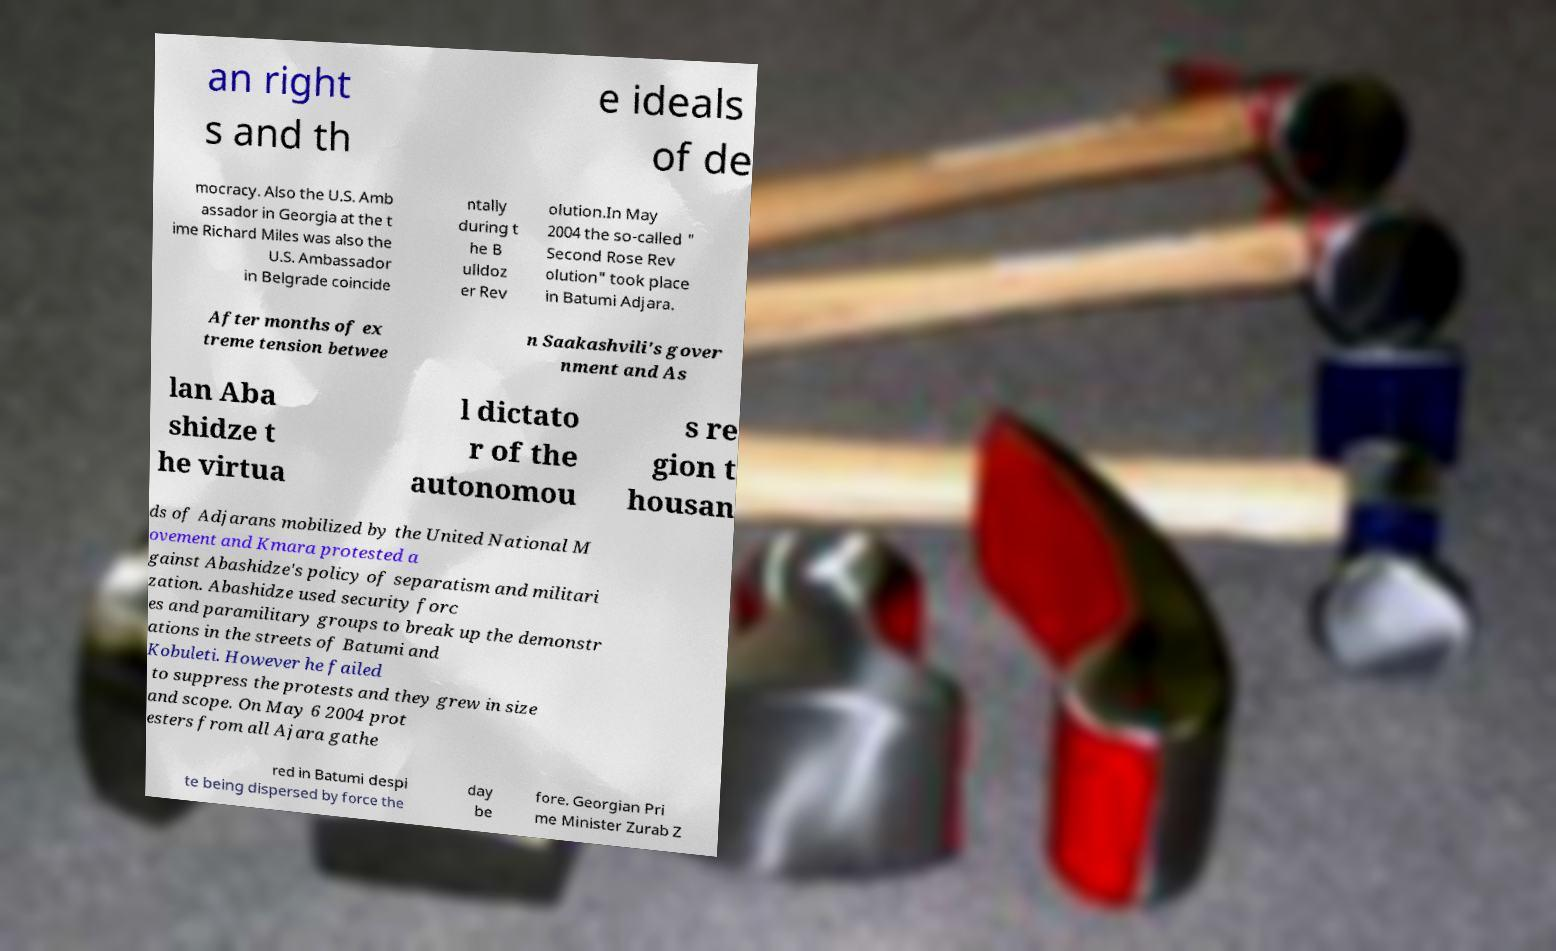I need the written content from this picture converted into text. Can you do that? an right s and th e ideals of de mocracy. Also the U.S. Amb assador in Georgia at the t ime Richard Miles was also the U.S. Ambassador in Belgrade coincide ntally during t he B ulldoz er Rev olution.In May 2004 the so-called " Second Rose Rev olution" took place in Batumi Adjara. After months of ex treme tension betwee n Saakashvili's gover nment and As lan Aba shidze t he virtua l dictato r of the autonomou s re gion t housan ds of Adjarans mobilized by the United National M ovement and Kmara protested a gainst Abashidze's policy of separatism and militari zation. Abashidze used security forc es and paramilitary groups to break up the demonstr ations in the streets of Batumi and Kobuleti. However he failed to suppress the protests and they grew in size and scope. On May 6 2004 prot esters from all Ajara gathe red in Batumi despi te being dispersed by force the day be fore. Georgian Pri me Minister Zurab Z 